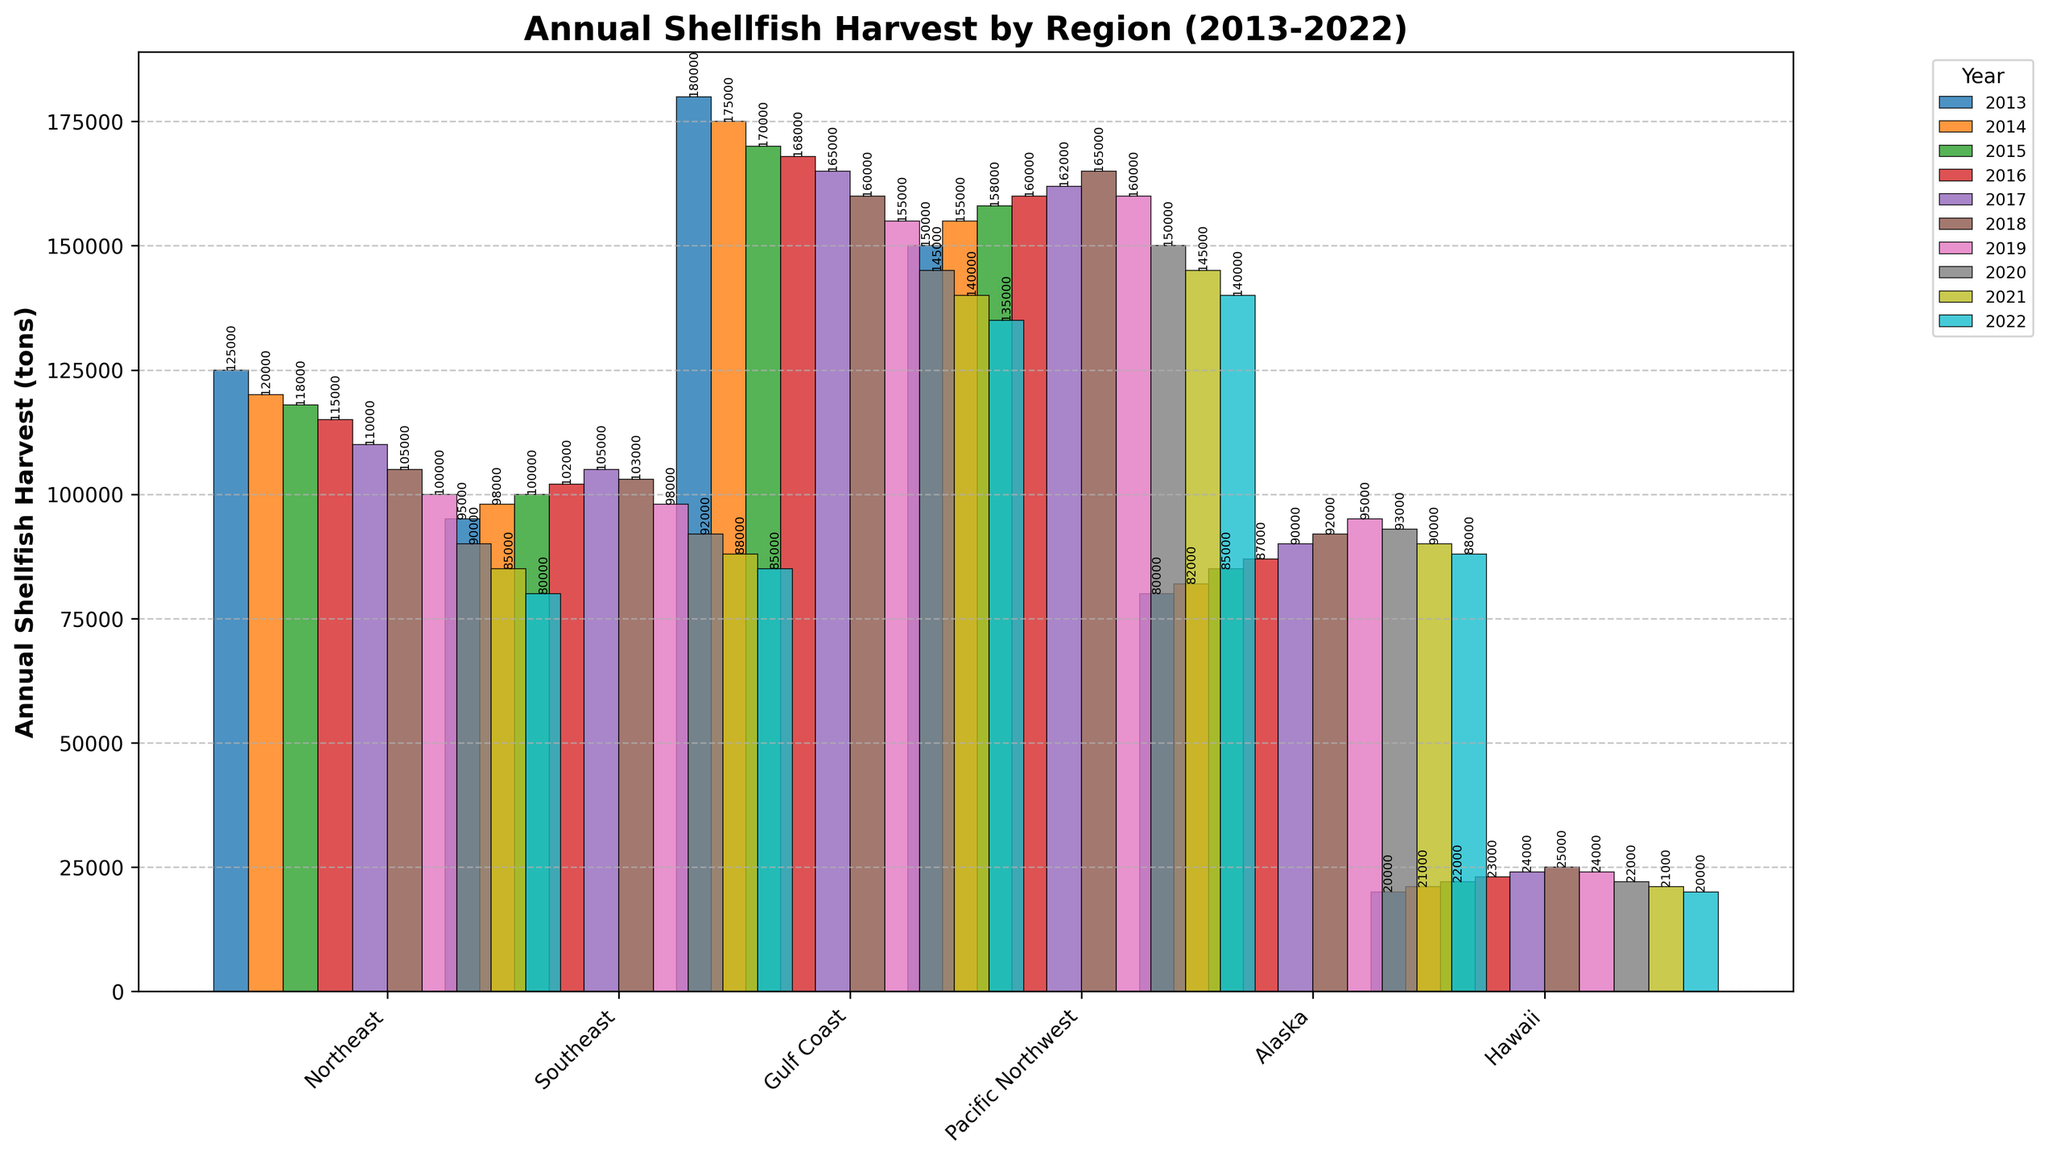What is the trend in the annual shellfish harvest for the Northeast region from 2013 to 2022? From the bars representing the Northeast region, we can see a consistent decline in the height of the bars from 2013 to 2022. This indicates a downward trend in the annual shellfish harvest over this decade.
Answer: Downward trend Which region had the highest annual shellfish harvest in 2018? On the bar chart, identify the tallest bar among all regions for the year 2018. The Gulf Coast has the highest annual shellfish harvest in 2018 compared to other regions.
Answer: Gulf Coast In 2022, how much more shellfish was harvested in the Gulf Coast compared to Hawaii? Look at the bar heights for 2022 in the Gulf Coast and Hawaii regions. The Gulf Coast harvested 135,000 tons, while Hawaii harvested 20,000 tons. Thus, the difference is 135,000 - 20,000 = 115,000 tons.
Answer: 115,000 tons Which year had the largest shellfish harvest in Alaska, and what was the quantity? Check the heights of the bars for Alaska between 2013 and 2022. The tallest bar occurs in 2019, which corresponds to a harvest of 95,000 tons.
Answer: 2019, 95,000 tons On average, how many tons of shellfish were harvested annually in the Pacific Northwest region from 2013 to 2022? Sum the quantities harvested in the Pacific Northwest from 2013 to 2022 and divide by the number of years. The values are 150,000 + 155,000 + 158,000 + 160,000 + 162,000 + 165,000 + 160,000 + 150,000 + 145,000 + 140,000 = 1,445,000 tons. The average per year is 1,445,000 / 10 = 144,500 tons.
Answer: 144,500 tons Is the annual shellfish harvest in the Southeast region in 2022 higher or lower than its average from 2013 to 2021? First, calculate the average for Southeast from 2013 to 2021: (95,000 + 98,000 + 100,000 + 102,000 + 105,000 + 103,000 + 98,000 + 92,000 + 88,000) / 9 = 88,442 tons approximately. The value for 2022 is 85,000 tons, which is less than the average of 88,442 tons.
Answer: Lower Which regions had a decline in shellfish harvest quantity from 2019 to 2022? Identify regions where the height of bars decreased from 2019 to 2022. These regions include the Northeast, Gulf Coast, Pacific Northwest, and Hawaii.
Answer: Northeast, Gulf Coast, Pacific Northwest, Hawaii What is the percentage decrease in shellfish harvest for the Northeast region from 2013 to 2022? Calculate the initial and final quantities: 125,000 tons in 2013 and 80,000 tons in 2022. The decrease is 125,000 - 80,000 = 45,000 tons. The percentage decrease is (45,000 / 125,000) * 100 = 36%.
Answer: 36% Between which consecutive years did the Gulf Coast region experience the largest decrease in shellfish harvest? Observe the difference between consecutive years for the Gulf Coast and find the largest drop: 180,000 - 175,000 = 5,000 (2013-2014), 175,000 - 170,000 = 5,000 (2014-2015), 170,000 - 168,000 = 2,000 (2015-2016), 168,000 - 165,000 = 3,000 (2016-2017), 165,000 - 160,000 = 5,000 (2017-2018), 160,000 - 155,000 = 5,000 (2018-2019), 155,000 - 145,000 = 10,000 (2019-2020), 145,000 - 140,000 = 5,000 (2020-2021), 140,000 - 135,000 = 5,000 (2021-2022). The largest decrease is 10,000 tons between 2019 and 2020.
Answer: 2019-2020 